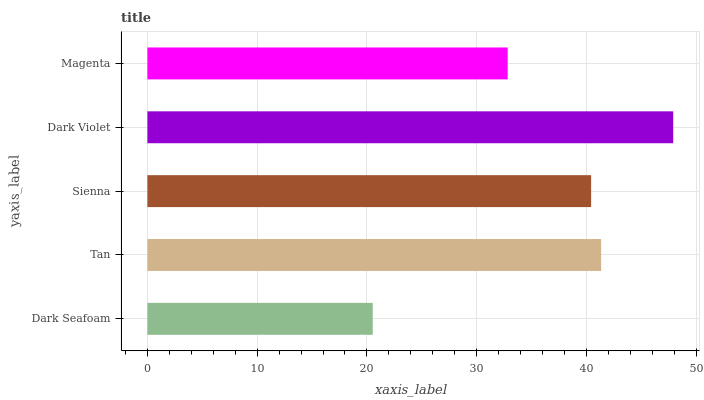Is Dark Seafoam the minimum?
Answer yes or no. Yes. Is Dark Violet the maximum?
Answer yes or no. Yes. Is Tan the minimum?
Answer yes or no. No. Is Tan the maximum?
Answer yes or no. No. Is Tan greater than Dark Seafoam?
Answer yes or no. Yes. Is Dark Seafoam less than Tan?
Answer yes or no. Yes. Is Dark Seafoam greater than Tan?
Answer yes or no. No. Is Tan less than Dark Seafoam?
Answer yes or no. No. Is Sienna the high median?
Answer yes or no. Yes. Is Sienna the low median?
Answer yes or no. Yes. Is Magenta the high median?
Answer yes or no. No. Is Dark Seafoam the low median?
Answer yes or no. No. 